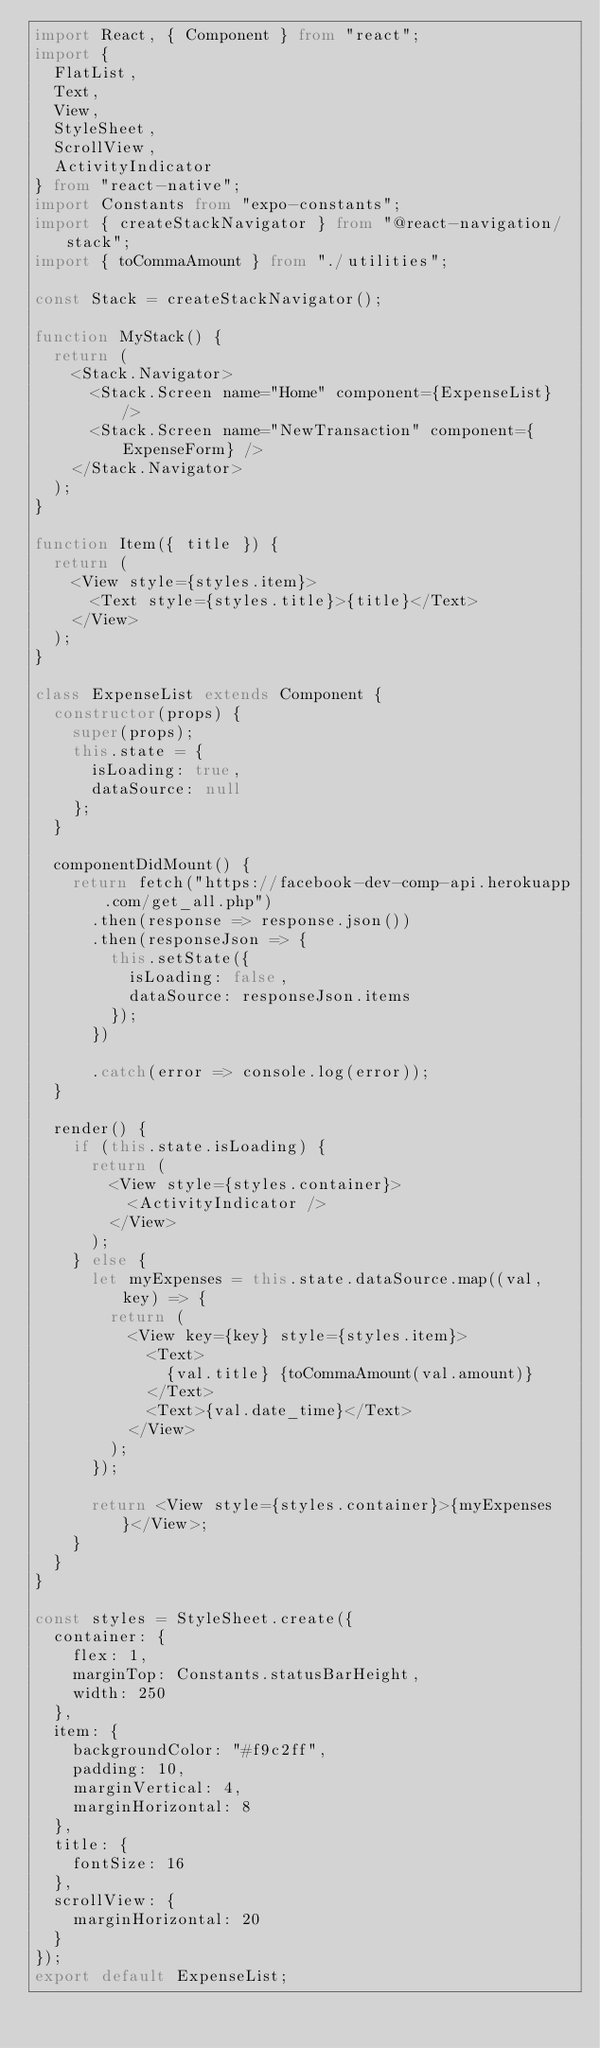<code> <loc_0><loc_0><loc_500><loc_500><_TypeScript_>import React, { Component } from "react";
import {
  FlatList,
  Text,
  View,
  StyleSheet,
  ScrollView,
  ActivityIndicator
} from "react-native";
import Constants from "expo-constants";
import { createStackNavigator } from "@react-navigation/stack";
import { toCommaAmount } from "./utilities";

const Stack = createStackNavigator();

function MyStack() {
  return (
    <Stack.Navigator>
      <Stack.Screen name="Home" component={ExpenseList} />
      <Stack.Screen name="NewTransaction" component={ExpenseForm} />
    </Stack.Navigator>
  );
}

function Item({ title }) {
  return (
    <View style={styles.item}>
      <Text style={styles.title}>{title}</Text>
    </View>
  );
}

class ExpenseList extends Component {
  constructor(props) {
    super(props);
    this.state = {
      isLoading: true,
      dataSource: null
    };
  }

  componentDidMount() {
    return fetch("https://facebook-dev-comp-api.herokuapp.com/get_all.php")
      .then(response => response.json())
      .then(responseJson => {
        this.setState({
          isLoading: false,
          dataSource: responseJson.items
        });
      })

      .catch(error => console.log(error));
  }

  render() {
    if (this.state.isLoading) {
      return (
        <View style={styles.container}>
          <ActivityIndicator />
        </View>
      );
    } else {
      let myExpenses = this.state.dataSource.map((val, key) => {
        return (
          <View key={key} style={styles.item}>
            <Text>
              {val.title} {toCommaAmount(val.amount)}
            </Text>
            <Text>{val.date_time}</Text>
          </View>
        );
      });

      return <View style={styles.container}>{myExpenses}</View>;
    }
  }
}

const styles = StyleSheet.create({
  container: {
    flex: 1,
    marginTop: Constants.statusBarHeight,
    width: 250
  },
  item: {
    backgroundColor: "#f9c2ff",
    padding: 10,
    marginVertical: 4,
    marginHorizontal: 8
  },
  title: {
    fontSize: 16
  },
  scrollView: {
    marginHorizontal: 20
  }
});
export default ExpenseList;
</code> 